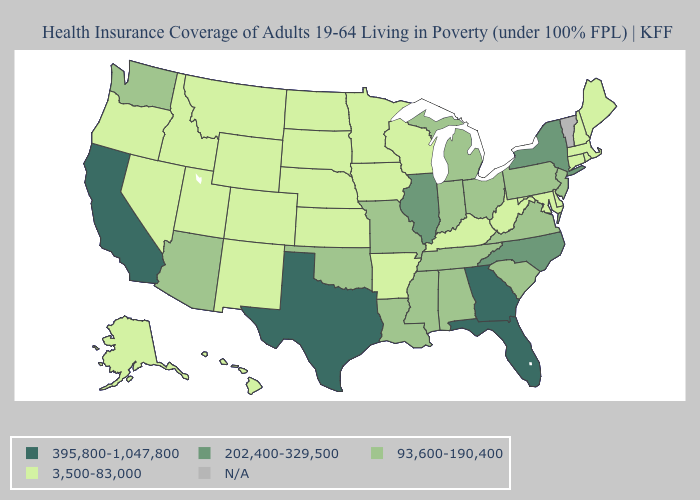Does Kentucky have the lowest value in the South?
Quick response, please. Yes. Name the states that have a value in the range N/A?
Give a very brief answer. Vermont. Name the states that have a value in the range 93,600-190,400?
Concise answer only. Alabama, Arizona, Indiana, Louisiana, Michigan, Mississippi, Missouri, New Jersey, Ohio, Oklahoma, Pennsylvania, South Carolina, Tennessee, Virginia, Washington. What is the highest value in the South ?
Concise answer only. 395,800-1,047,800. Does Kentucky have the highest value in the South?
Quick response, please. No. What is the highest value in states that border Nebraska?
Give a very brief answer. 93,600-190,400. Among the states that border New Mexico , does Arizona have the lowest value?
Answer briefly. No. Name the states that have a value in the range N/A?
Write a very short answer. Vermont. Among the states that border Alabama , does Tennessee have the lowest value?
Be succinct. Yes. Among the states that border Ohio , does Kentucky have the lowest value?
Give a very brief answer. Yes. Among the states that border Iowa , which have the highest value?
Concise answer only. Illinois. Name the states that have a value in the range N/A?
Be succinct. Vermont. 